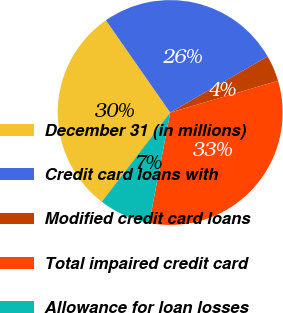Convert chart. <chart><loc_0><loc_0><loc_500><loc_500><pie_chart><fcel>December 31 (in millions)<fcel>Credit card loans with<fcel>Modified credit card loans<fcel>Total impaired credit card<fcel>Allowance for loan losses<nl><fcel>29.91%<fcel>26.36%<fcel>3.77%<fcel>32.54%<fcel>7.42%<nl></chart> 